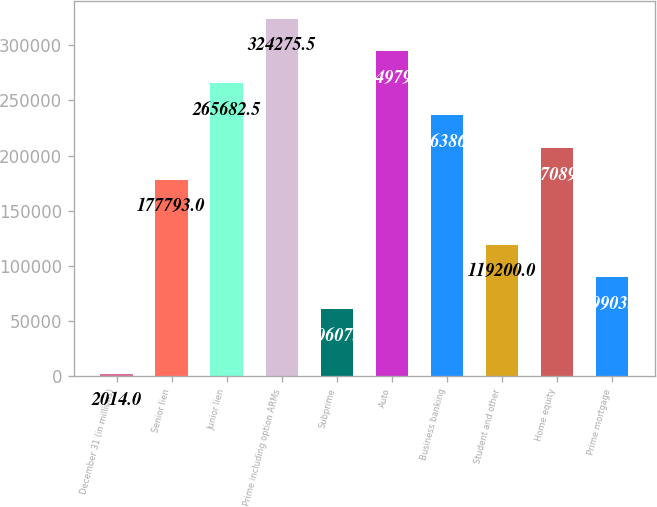Convert chart to OTSL. <chart><loc_0><loc_0><loc_500><loc_500><bar_chart><fcel>December 31 (in millions)<fcel>Senior lien<fcel>Junior lien<fcel>Prime including option ARMs<fcel>Subprime<fcel>Auto<fcel>Business banking<fcel>Student and other<fcel>Home equity<fcel>Prime mortgage<nl><fcel>2014<fcel>177793<fcel>265682<fcel>324276<fcel>60607<fcel>294979<fcel>236386<fcel>119200<fcel>207090<fcel>89903.5<nl></chart> 